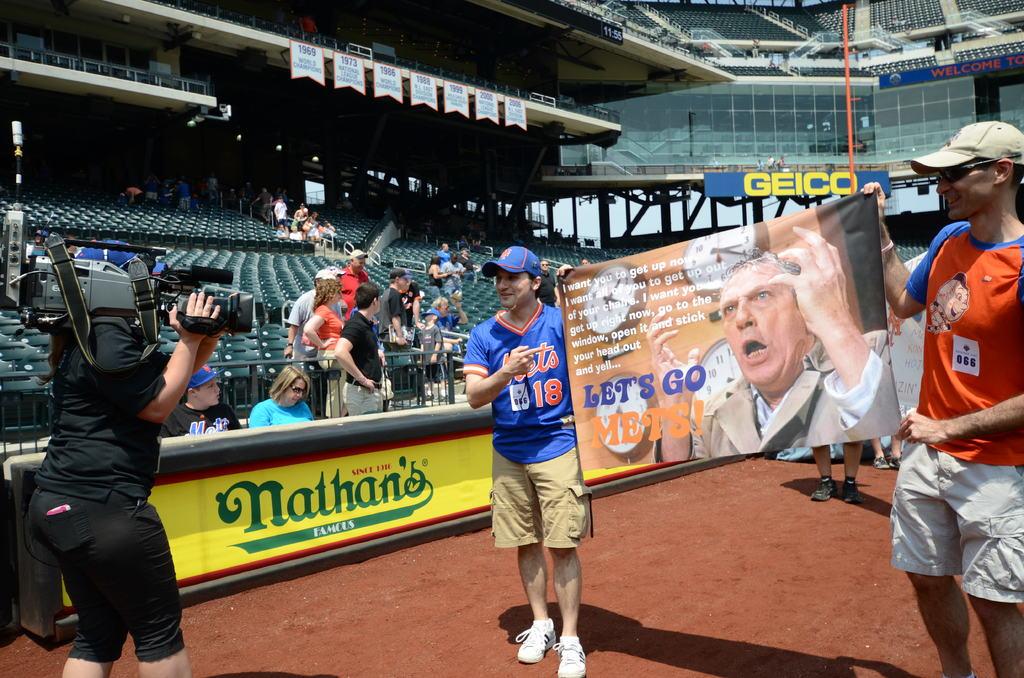What number met's shirt is he wearing?
Your response must be concise. 18. Is nathan's a famous hot dog restaurant?
Your response must be concise. Yes. 